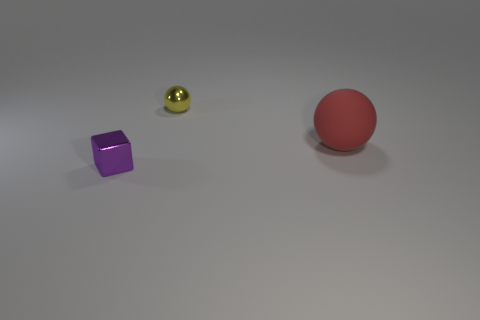Add 3 tiny things. How many objects exist? 6 Subtract 0 blue cylinders. How many objects are left? 3 Subtract all blocks. How many objects are left? 2 Subtract all yellow spheres. Subtract all blue cylinders. How many spheres are left? 1 Subtract all blue spheres. How many cyan blocks are left? 0 Subtract all rubber things. Subtract all purple cubes. How many objects are left? 1 Add 1 purple metallic objects. How many purple metallic objects are left? 2 Add 2 big blue cylinders. How many big blue cylinders exist? 2 